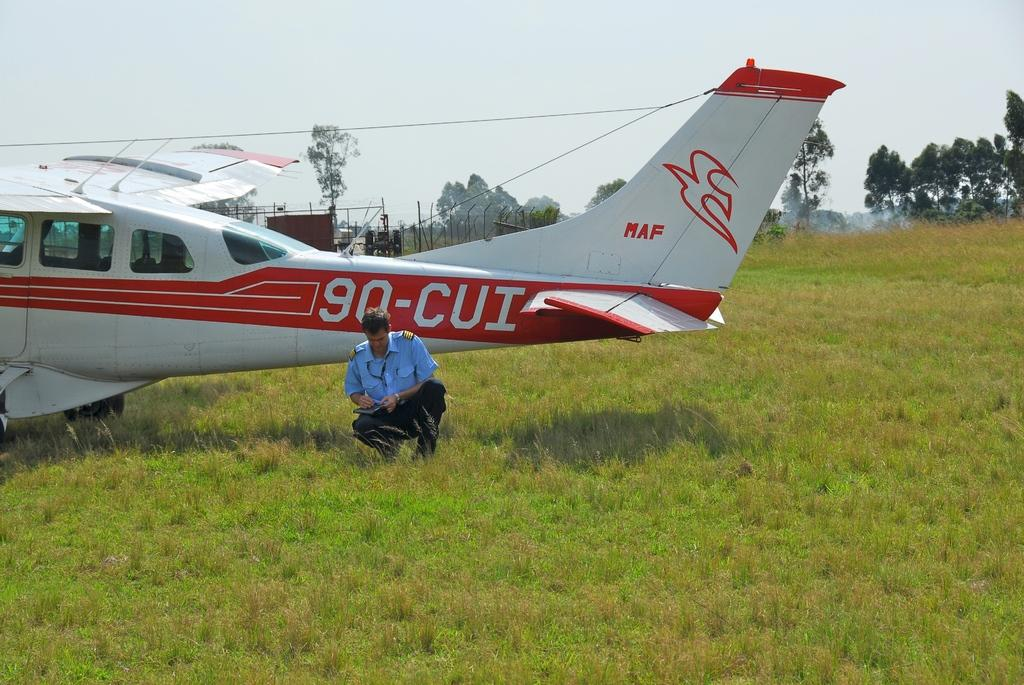<image>
Offer a succinct explanation of the picture presented. A small orange and white private plane is labeled on its side with the ID number 90-CUI. 